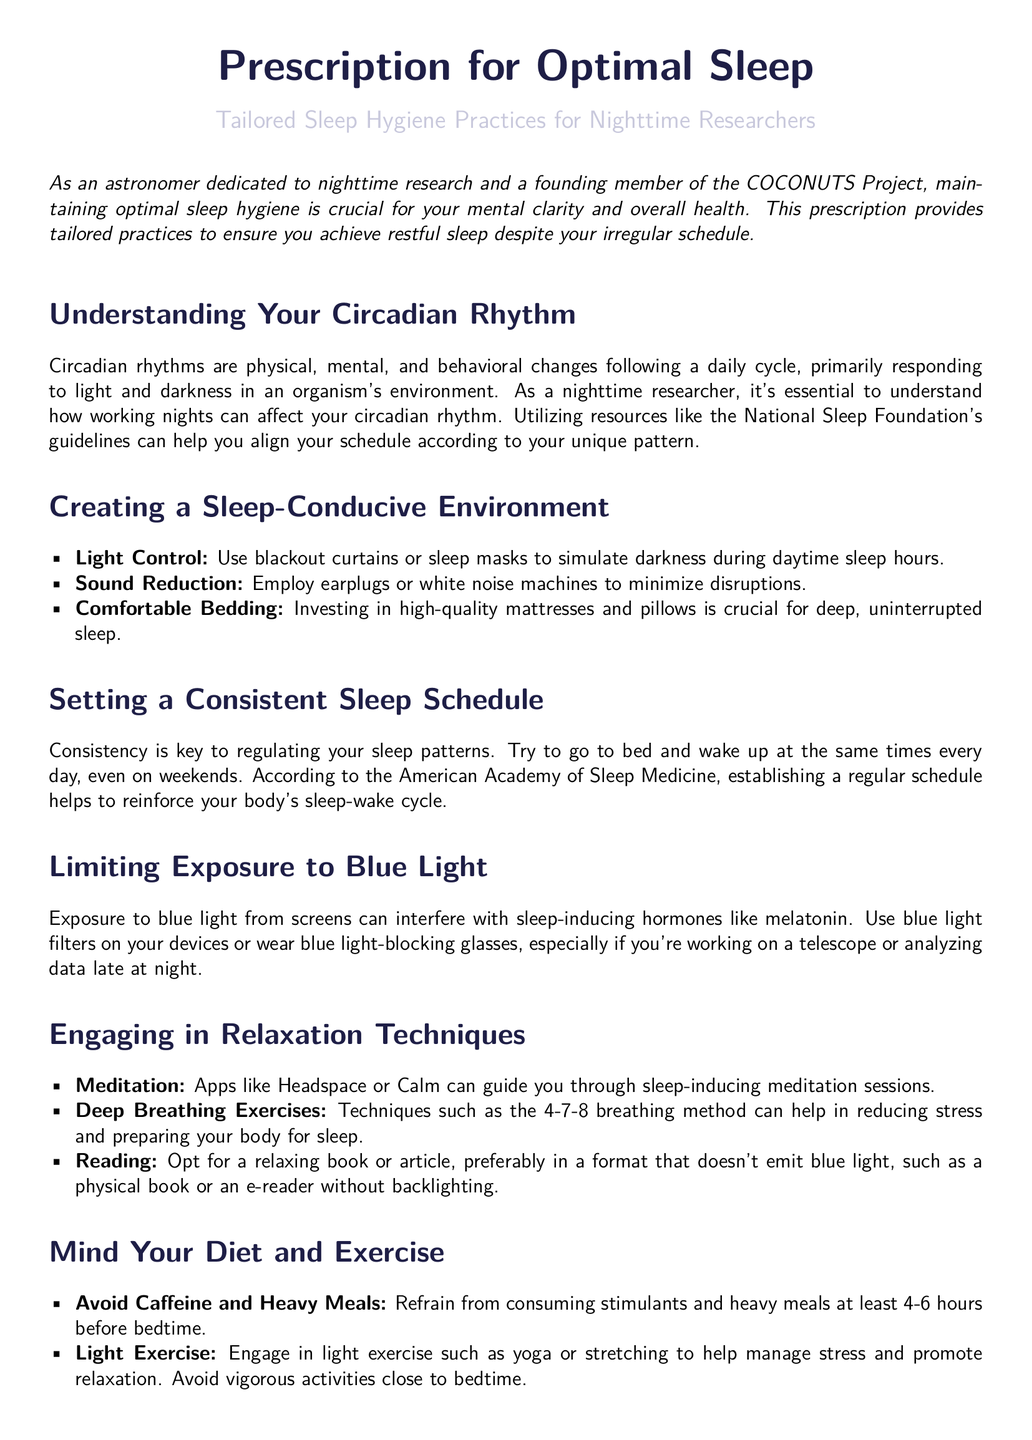What is the main topic of the document? The main topic is centered around sleep hygiene practices tailored for nighttime researchers, particularly astronomers.
Answer: Optimal Sleep What should be avoided at least 4-6 hours before bedtime? The document suggests refraining from consuming stimulants and heavy meals to promote better sleep.
Answer: Caffeine and Heavy Meals What technique is recommended for sound reduction? The document lists earplugs or white noise machines as effective ways to minimize disruptions during sleep.
Answer: Earplugs or White Noise Machines According to the document, what can help adjust circadian rhythms? Melatonin supplements are mentioned as a natural method for adjusting sleep patterns and circadian rhythms.
Answer: Melatonin Supplements What is a key factor in regulating sleep patterns? The document emphasizes that consistency in sleep/wake times is essential for maintaining a healthy sleep cycle.
Answer: Consistent Sleep Schedule What devices' blue light should be limited? The document specifically mentions limiting exposure to blue light from screens as an important practice for better sleep.
Answer: Screens Which meditation apps are recommended for relaxation? The document mentions Headspace and Calm as resources for guided meditation aimed at improving sleep.
Answer: Headspace or Calm What is the suggested light exercise before bedtime? Engaging in yoga or stretching is advised as a light exercise to promote relaxation before sleep.
Answer: Yoga or Stretching What type of bedding should be invested in for optimal sleep? High-quality mattresses and pillows are highlighted as critical for achieving deep, uninterrupted sleep.
Answer: Comfortable Bedding 